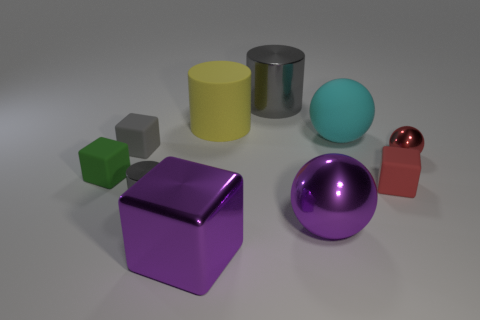If you had to guess, what's the setting of this collection of objects? This collection of objects could be set in a number of places, like an artist's studio for a still life arrangement, a classroom for a lesson on geometry and colors, or even a showcase for materials in a design setting. The neutral background and professional lighting suggest the objects are laid out intentionally for observation or display. 